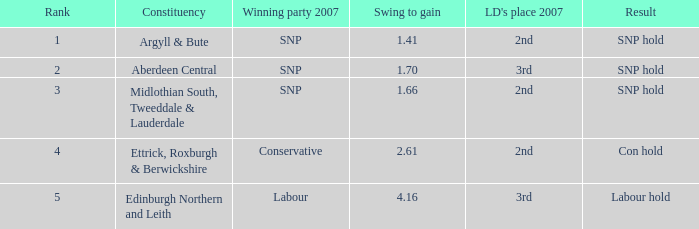In a constituency with a swing to gain under 4.16, where the winning party in 2007 was snp and ld ranked 2nd, what is the name of the constituency? Argyll & Bute, Midlothian South, Tweeddale & Lauderdale. 